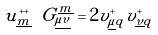Convert formula to latex. <formula><loc_0><loc_0><loc_500><loc_500>u ^ { + + } _ { \underline { m } } \ G ^ { \underline { m } } _ { \underline { \mu \nu } } = 2 v ^ { + } _ { \underline { \mu } q } v ^ { + } _ { \underline { \nu } q }</formula> 